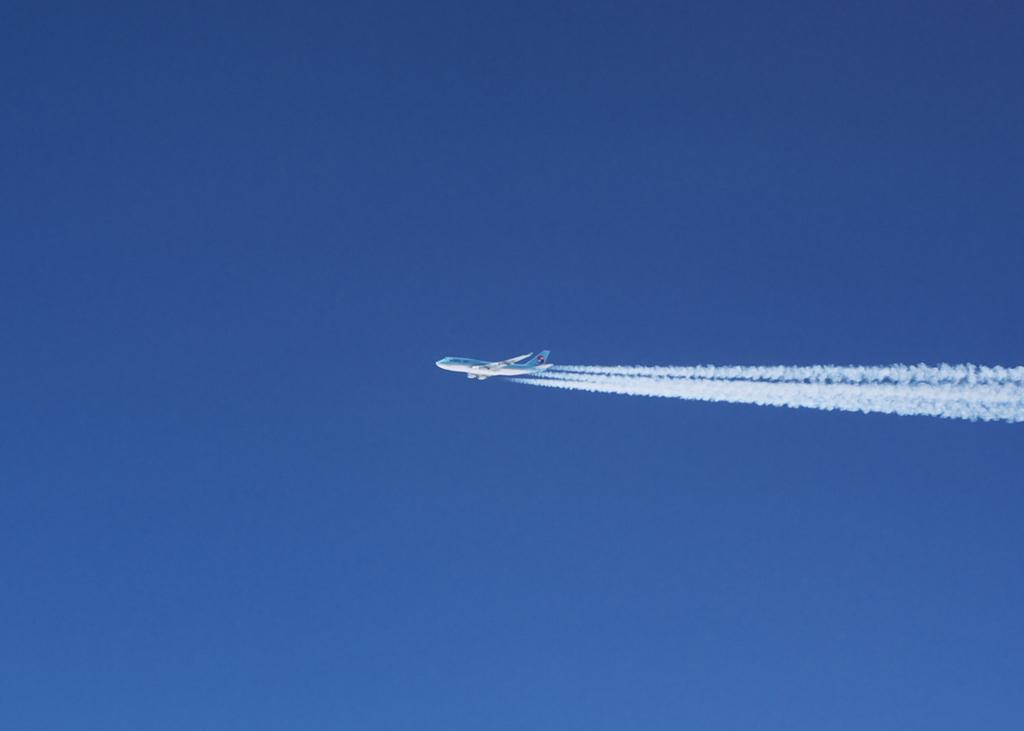In one or two sentences, can you explain what this image depicts? This image is taken outdoors. In the background there is a sky. In the middle of the image an airplane is flying in the sky and there is a smoke. 